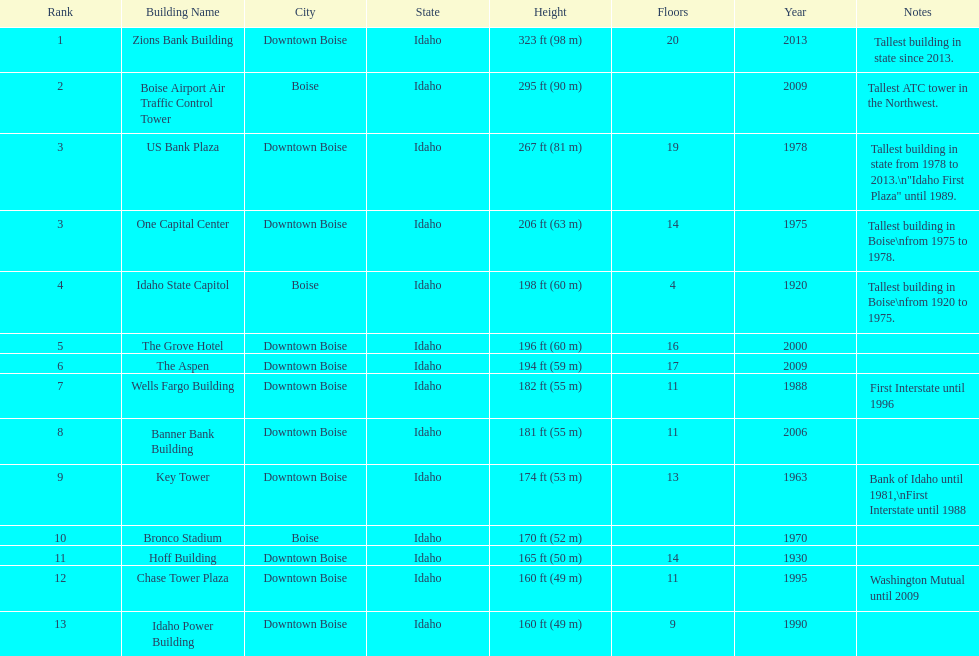How many buildings have at least ten floors? 10. 